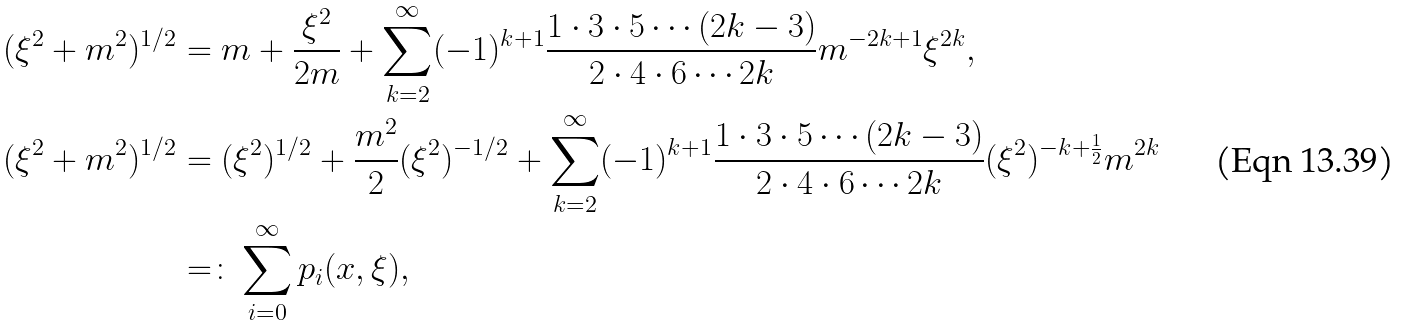Convert formula to latex. <formula><loc_0><loc_0><loc_500><loc_500>( \xi ^ { 2 } + m ^ { 2 } ) ^ { 1 / 2 } & = m + \frac { \xi ^ { 2 } } { 2 m } + \sum _ { k = 2 } ^ { \infty } ( - 1 ) ^ { k + 1 } \frac { 1 \cdot 3 \cdot 5 \cdots ( 2 k - 3 ) } { 2 \cdot 4 \cdot 6 \cdots 2 k } m ^ { - 2 k + 1 } \xi ^ { 2 k } , \\ ( \xi ^ { 2 } + m ^ { 2 } ) ^ { 1 / 2 } & = ( \xi ^ { 2 } ) ^ { 1 / 2 } + \frac { m ^ { 2 } } { 2 } ( \xi ^ { 2 } ) ^ { - 1 / 2 } + \sum _ { k = 2 } ^ { \infty } ( - 1 ) ^ { k + 1 } \frac { 1 \cdot 3 \cdot 5 \cdots ( 2 k - 3 ) } { 2 \cdot 4 \cdot 6 \cdots 2 k } ( \xi ^ { 2 } ) ^ { - k + \frac { 1 } { 2 } } m ^ { 2 k } \\ & = \colon \sum _ { i = 0 } ^ { \infty } p _ { i } ( x , \xi ) ,</formula> 